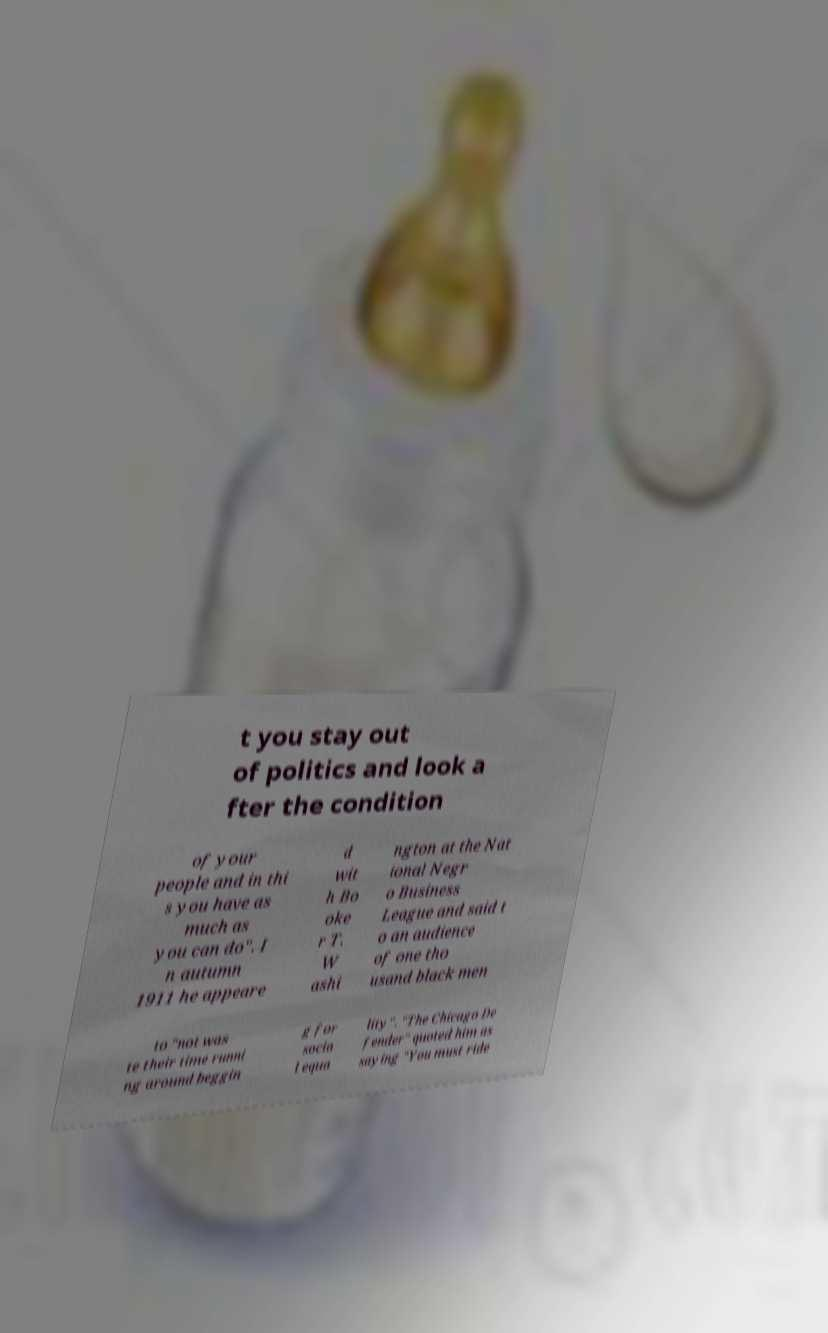Can you accurately transcribe the text from the provided image for me? t you stay out of politics and look a fter the condition of your people and in thi s you have as much as you can do". I n autumn 1911 he appeare d wit h Bo oke r T. W ashi ngton at the Nat ional Negr o Business League and said t o an audience of one tho usand black men to "not was te their time runni ng around beggin g for socia l equa lity". "The Chicago De fender" quoted him as saying "You must ride 